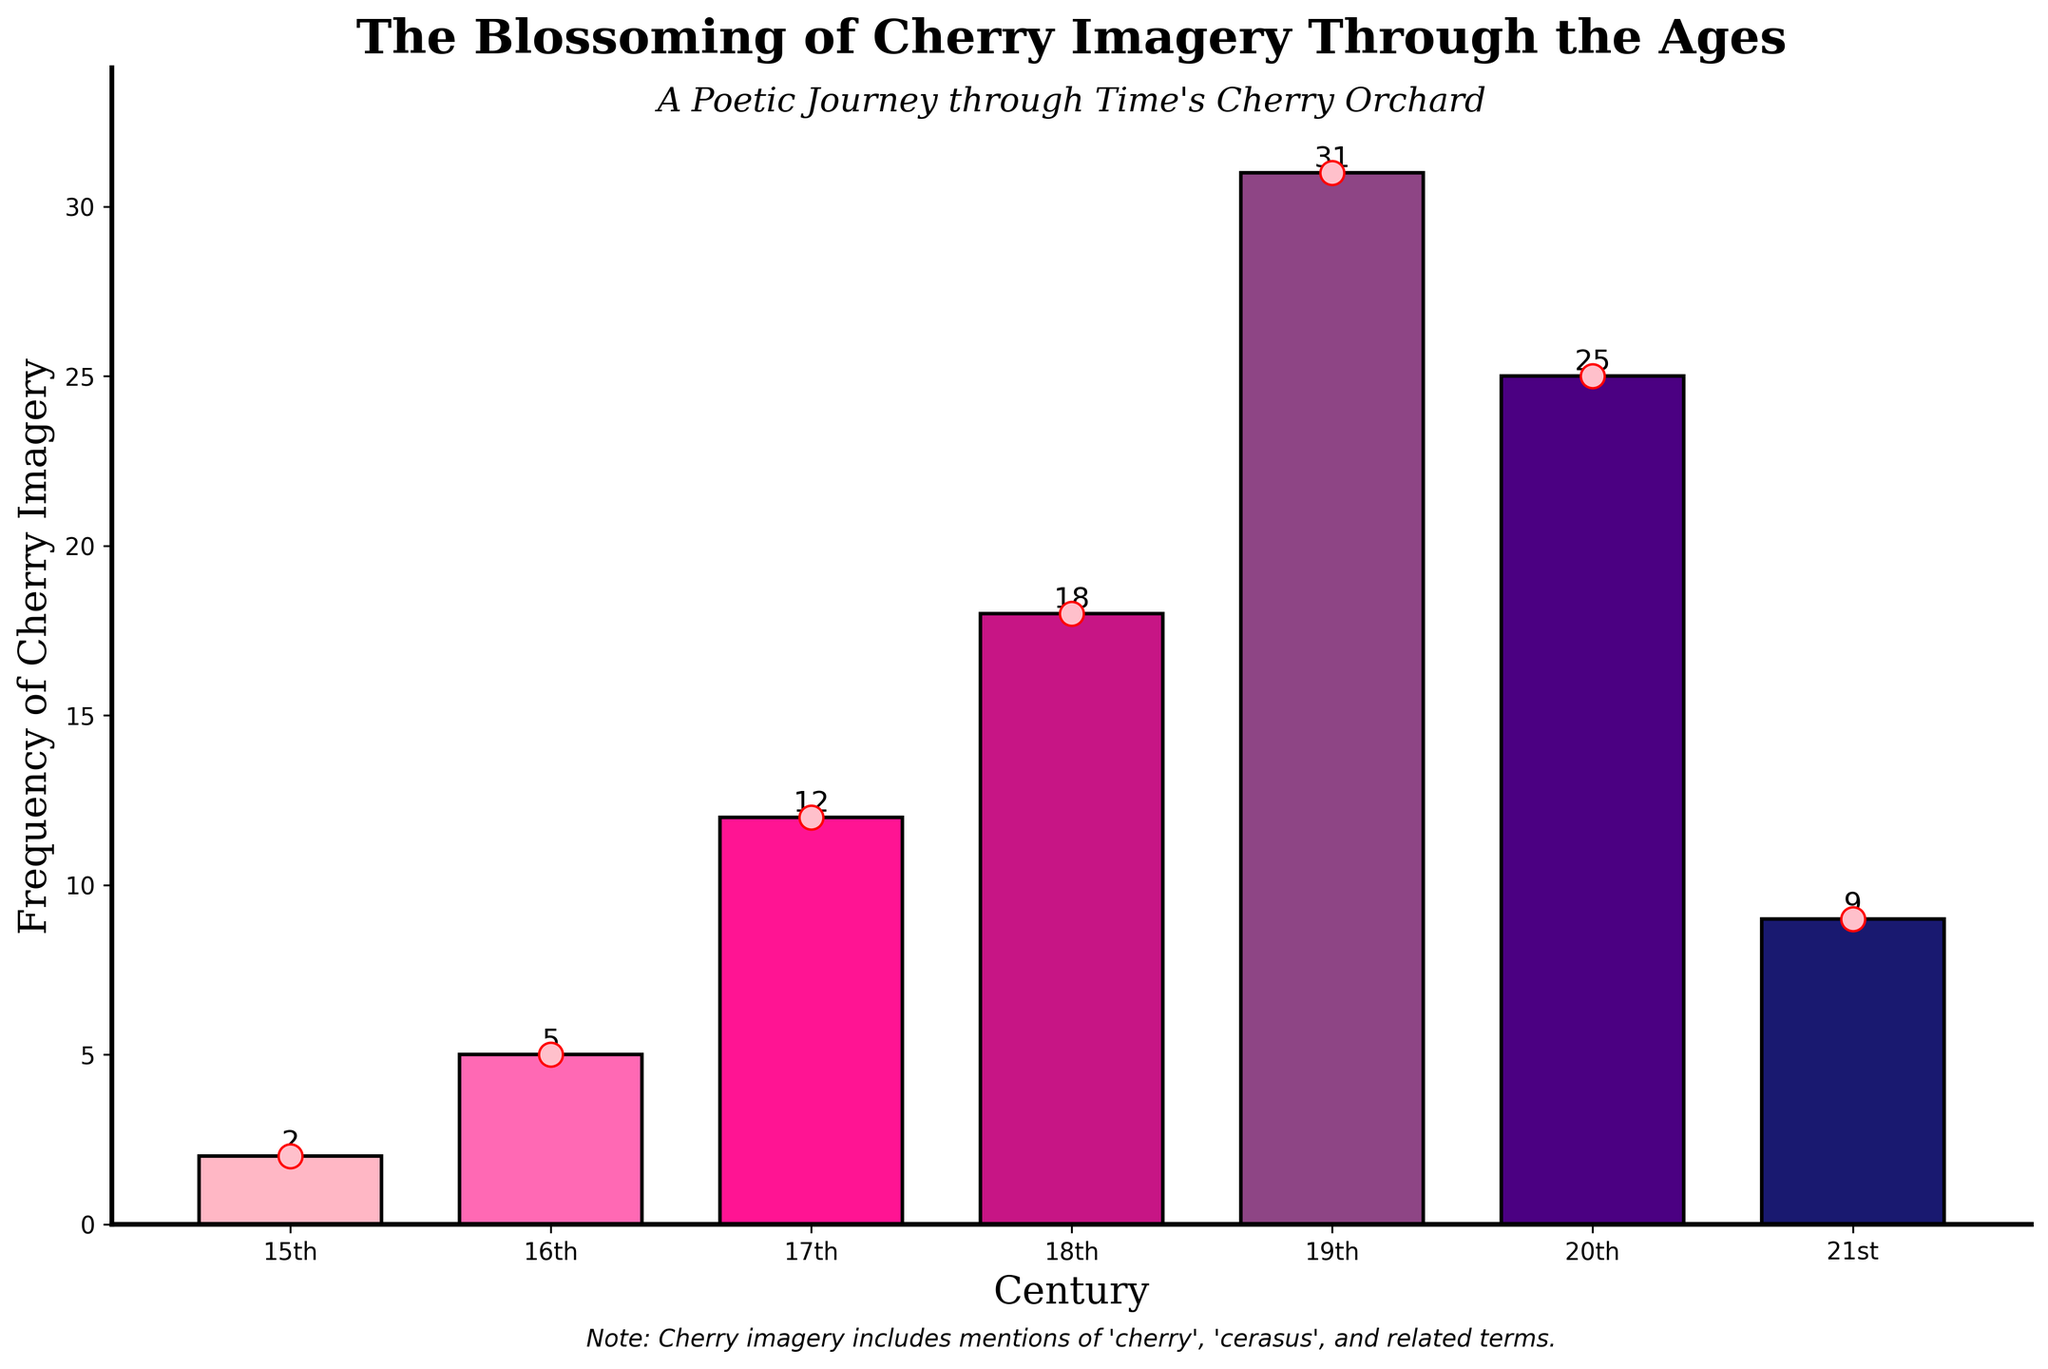How many more mentions of cherry imagery are there in the 19th century compared to the 21st century? In the 19th century, there are 31 mentions, and in the 21st century, there are 9 mentions. The difference is 31 - 9 = 22.
Answer: 22 Which century has the highest frequency of cherry imagery, and what is that frequency? By examining the heights of the bars for each century, the 19th century has the highest frequency with 31 mentions.
Answer: 19th century, 31 Is the frequency of cherry imagery higher in the 18th century or the 16th century, and by how much? The 18th century has a frequency of 18 mentions and the 16th century has a frequency of 5. The difference is 18 - 5 = 13.
Answer: 18th century, 13 What is the combined frequency of cherry imagery for the 15th, 16th, and 17th centuries? The frequencies for the 15th, 16th, and 17th centuries are 2, 5, and 12 respectively. The combined frequency is 2 + 5 + 12 = 19.
Answer: 19 Which bar is colored darkest, and what frequency does it represent? The bar representing the 21st century is the darkest and it corresponds to a frequency of 9.
Answer: 21st century, 9 Between which two consecutive centuries is the largest increase in cherry imagery frequency observed? From the 16th century (5) to the 17th century (12) there's an increase of 7, and from the 17th century (12) to the 18th century (18) there's an increase of 6. The increase from the 18th century (18) to the 19th century (31) is 13. Thus, the largest increase is from the 18th to the 19th century.
Answer: 18th to 19th century Calculate the average frequency of cherry imagery across all the centuries shown. The frequencies are 2, 5, 12, 18, 31, 25, and 9. The sum is 102 and there are 7 data points, so the average is 102 / 7 ≈ 14.57.
Answer: 14.57 Does the 20th century have more mentions of cherry imagery than the combined total of the 15th, 16th, and 17th centuries? The 20th century has 25 mentions. The sum of the 15th, 16th, and 17th centuries' mentions is 2 + 5 + 12 = 19. Since 25 > 19, the 20th century has more.
Answer: Yes What is the difference in frequency between the century with the least mentions and the century with the most mentions of cherry imagery? The 15th century has the least mentions with 2, and the 19th century has the most with 31. The difference is 31 - 2 = 29.
Answer: 29 Which two centuries have the same color bar, and what are their frequencies? No two centuries share the exact same color in this palette. Each century's bar is represented with a unique color.
Answer: None 